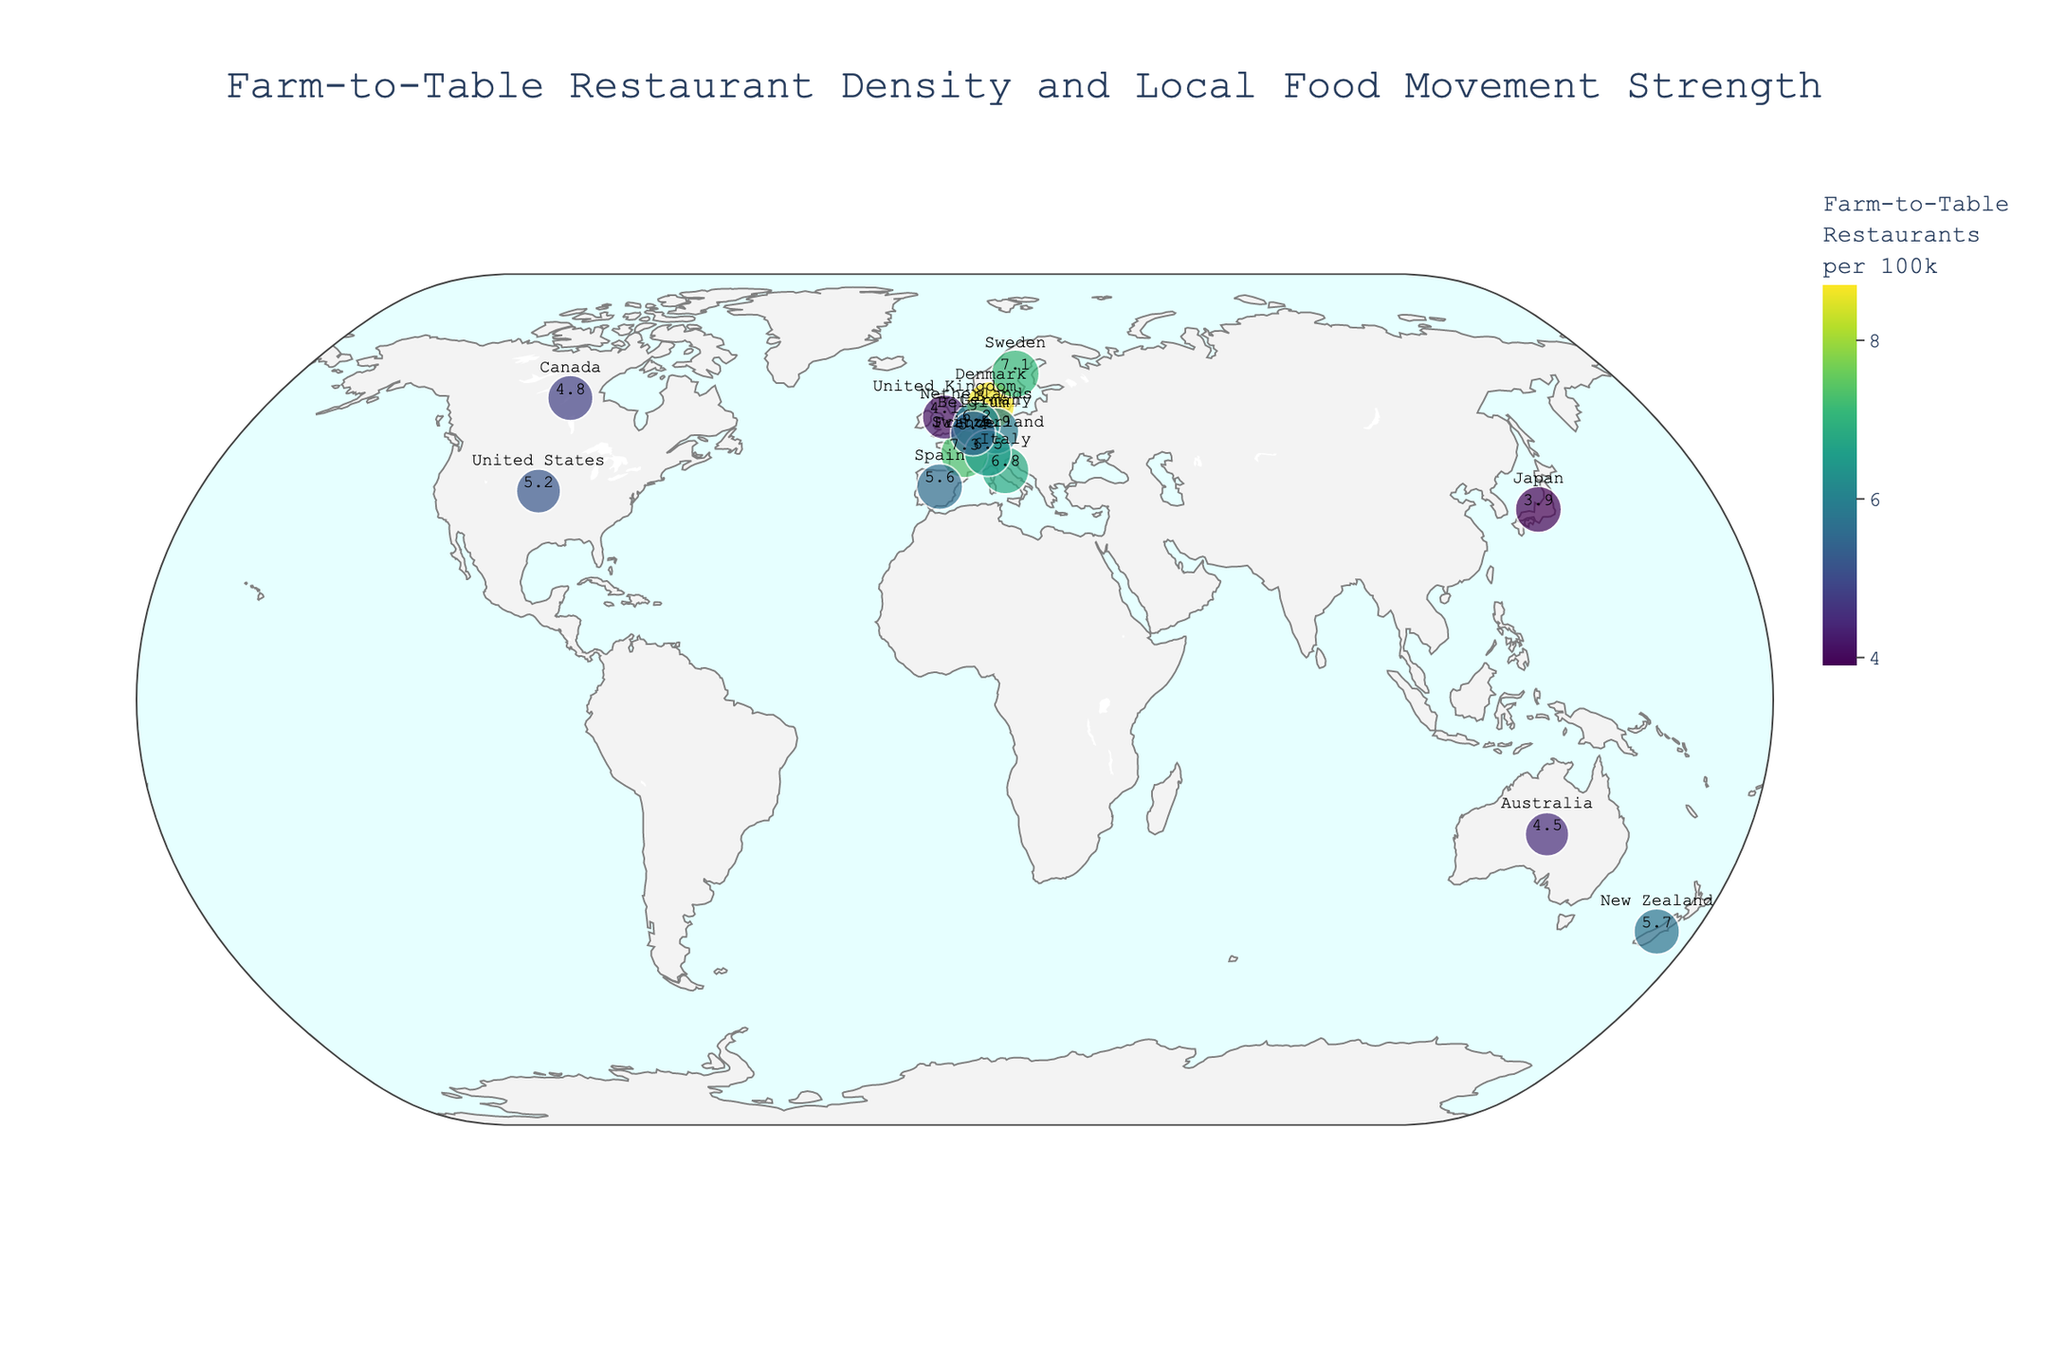1. What is the country with the highest density of farm-to-table restaurants? The country with the highest density of farm-to-table restaurants is the one with the largest value for the "Farm-to-Table Restaurants per 100k" attribute. From the figure, this value is highest for Denmark with 8.7 restaurants per 100k.
Answer: Denmark 2. How does the local food movement score for France compare to that of Canada? France has a local food movement score of 90, while Canada has a score of 82. Comparing these scores shows that France has a higher score by 8 points.
Answer: France has a higher score by 8 points 3. Which country has the lowest density of farm-to-table restaurants? To find the country with the lowest density, look for the smallest value in the "Farm-to-Table Restaurants per 100k" attribute. From the figure, Japan has the lowest density with 3.9 restaurants per 100k.
Answer: Japan 4. Are there any countries with a local food movement score above 90? From the figure, we need to identify countries with a local food movement score greater than 90. Denmark (92) and Sweden (91) are the countries meeting this criterion.
Answer: Yes, Denmark and Sweden 5. How many countries have a farm-to-table restaurant density greater than 6 per 100k? To answer this, count the number of countries with a value above 6 in the "Farm-to-Table Restaurants per 100k" attribute. The countries are Denmark, Italy, France, the Netherlands, Sweden, and Switzerland, giving a total of 6 countries.
Answer: 6 countries 6. Which country has the greatest visual size on the plot based on the local food movement score? The visual size of each country on the plot corresponds to their "Local Food Movement Score". The country with the largest score will have the greatest size. This is Denmark with a score of 92.
Answer: Denmark 7. How does Australia compare to New Zealand in terms of farm-to-table restaurant density and local food movement score? For farm-to-table restaurant density, Australia has 4.5 per 100k, and New Zealand has 5.7 per 100k. For local food movement scores, Australia has 76 and New Zealand has 83. New Zealand has higher values in both attributes.
Answer: New Zealand has higher values in both attributes 8. What is the average farm-to-table restaurant density of European countries in the plot? Identify the European countries: Denmark (8.7), Italy (6.8), France (7.3), Spain (5.6), United Kingdom (4.1), Germany (5.9), Netherlands (6.2), Sweden (7.1), Switzerland (6.5), Belgium (5.4). Sum these densities and divide by the number of countries. (8.7 + 6.8 + 7.3 + 5.6 + 4.1 + 5.9 + 6.2 + 7.1 + 6.5 + 5.4) / 10 = 63.6 / 10 = 6.36
Answer: 6.36 